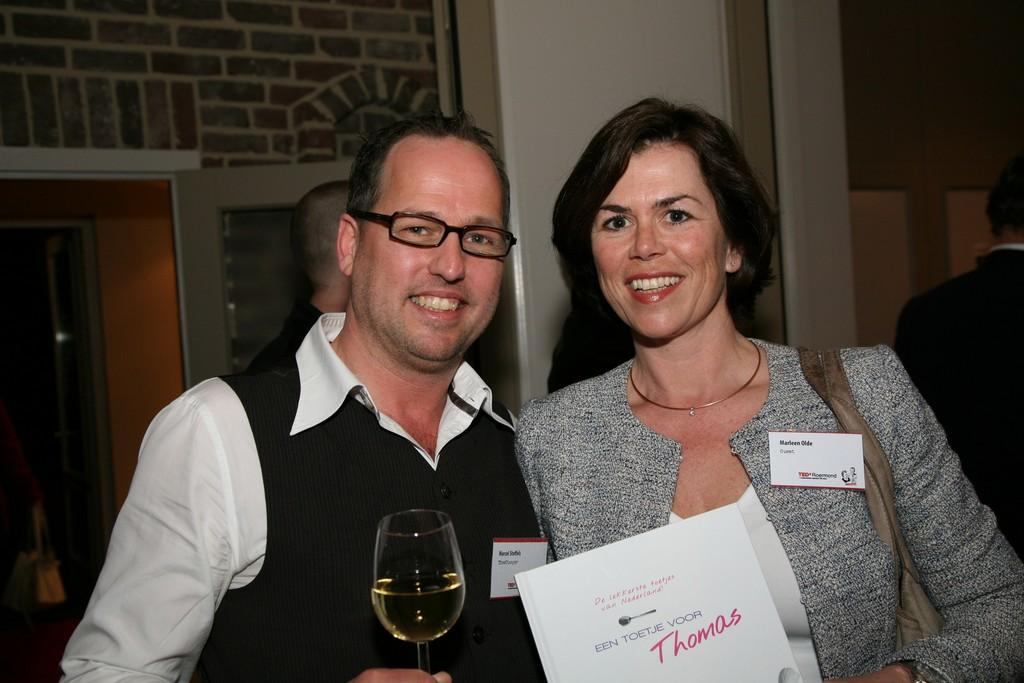Who is present in the image? There is a couple in the image. Where are the couple positioned in the image? The couple is standing in the front. What are the couple holding in the image? The couple is holding wine glasses. What are the couple doing in the image? The couple is giving a pose to the camera. What can be seen in the background of the image? There is an arch wall and a door in the background. What type of nail is being used by the couple to hold the bridge together in the image? There is no bridge or nail present in the image; it features a couple standing in front of an arch wall and a door. 